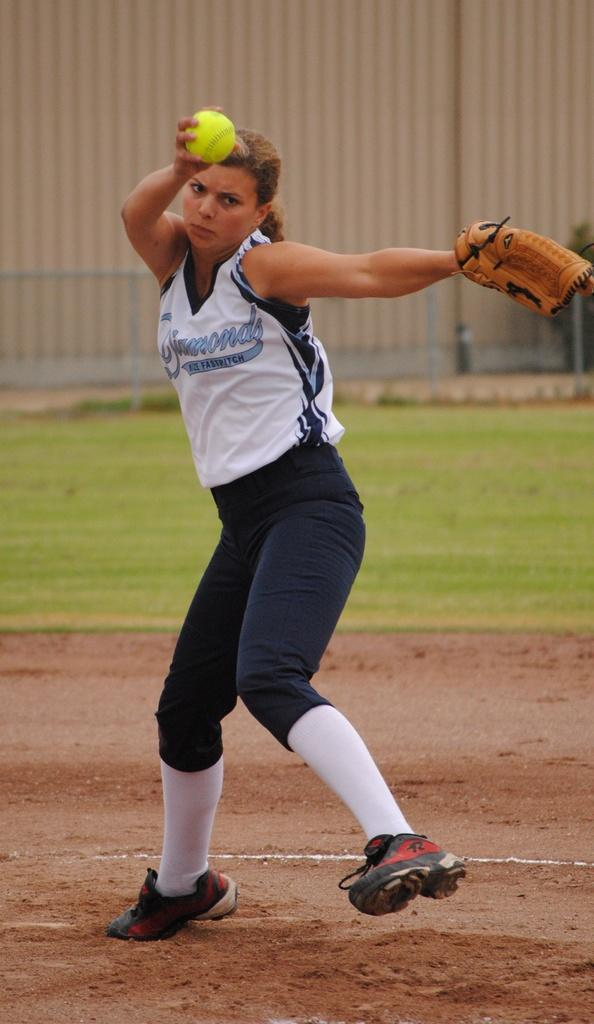<image>
Create a compact narrative representing the image presented. A woman whose shirt says "fastpitch" on it holds the ball out as she gets ready to throw it. 